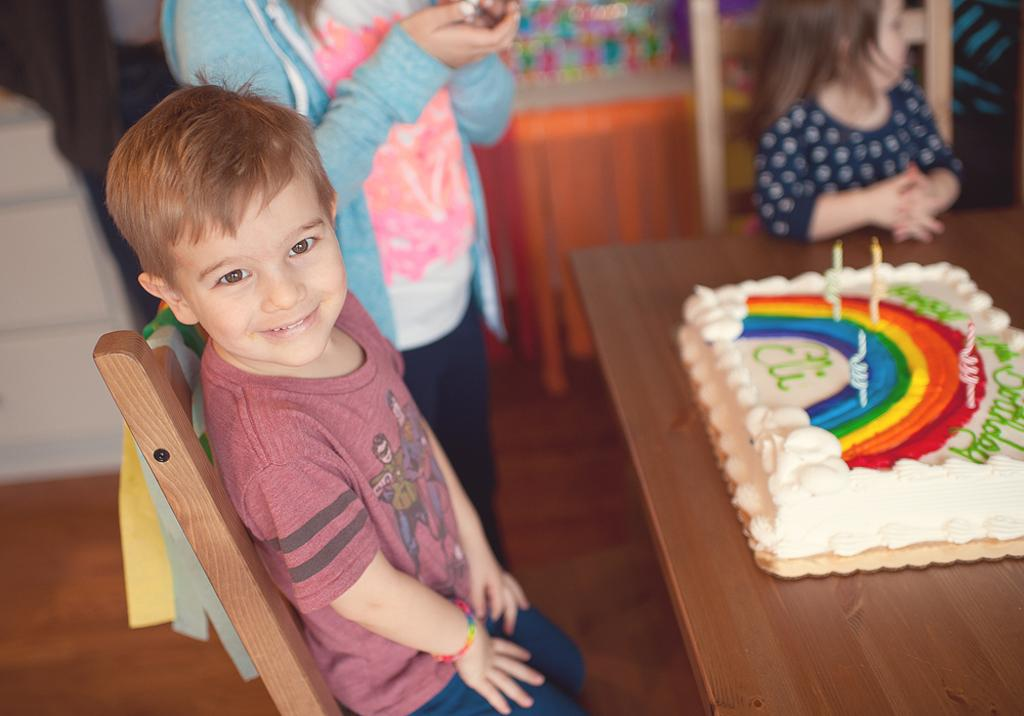Who is present in the image? There are children in the image. Where are the children located? The children are on the floor. What is on the table in the image? There is a cake with candles on a table in the image. What can be seen in the background of the image? There are objects visible in the background of the image. What type of yam is being used to decorate the cake in the image? There is no yam present in the image, and the cake does not appear to be decorated with yam. How many arms are visible in the image? The image does not show any arms; it primarily features children and a cake with candles on a table. 